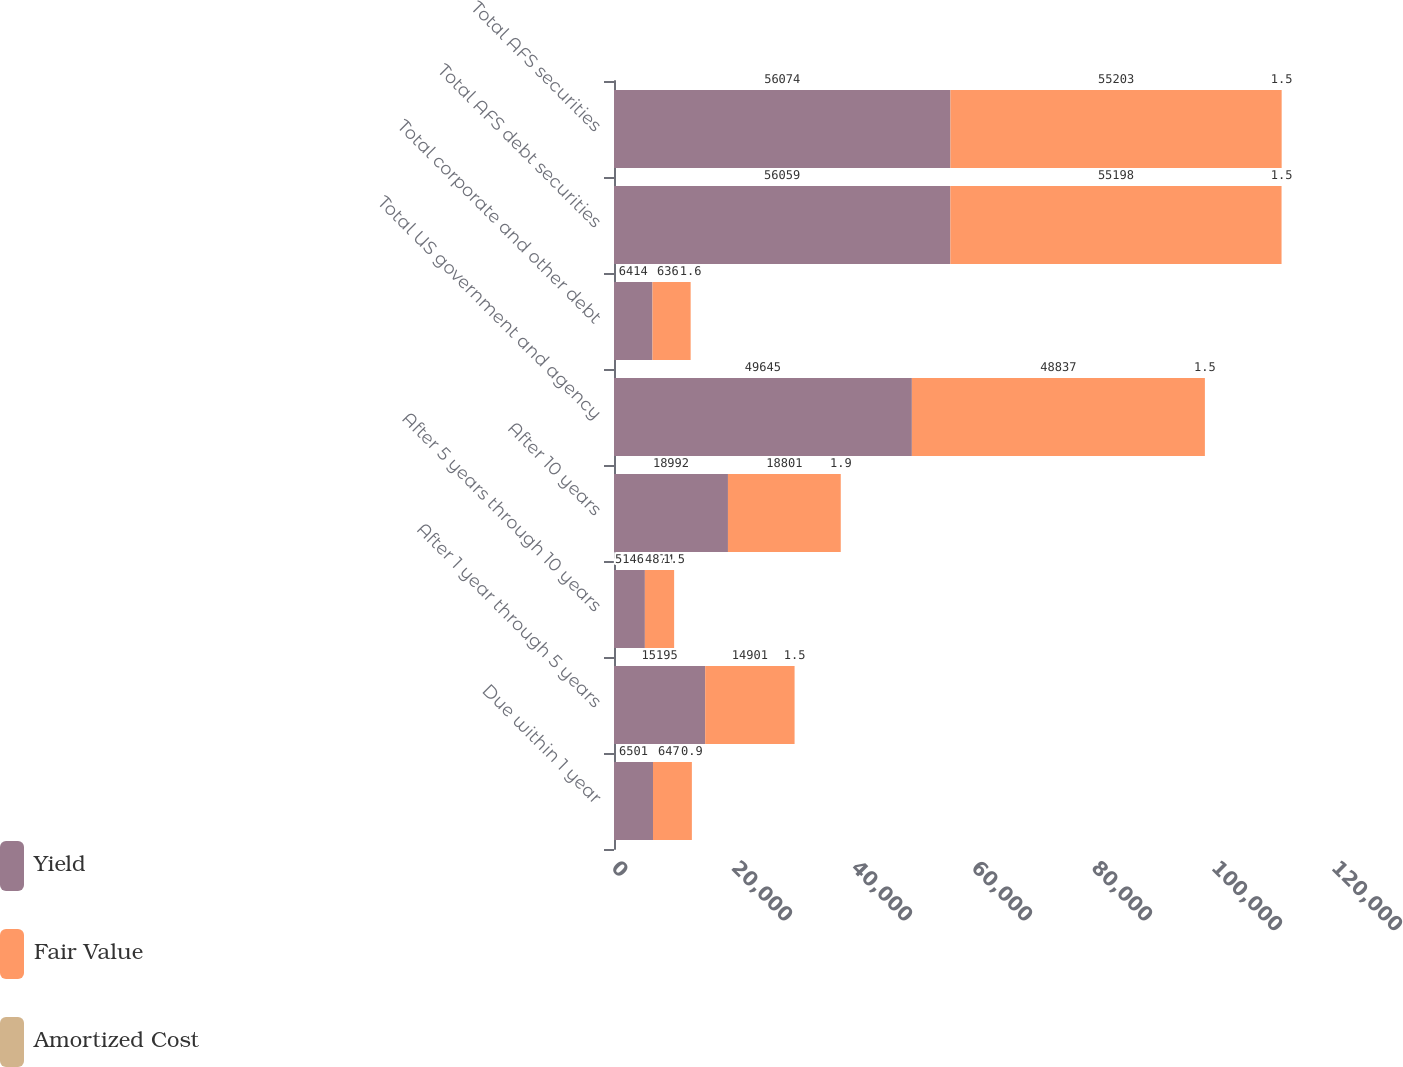<chart> <loc_0><loc_0><loc_500><loc_500><stacked_bar_chart><ecel><fcel>Due within 1 year<fcel>After 1 year through 5 years<fcel>After 5 years through 10 years<fcel>After 10 years<fcel>Total US government and agency<fcel>Total corporate and other debt<fcel>Total AFS debt securities<fcel>Total AFS securities<nl><fcel>Yield<fcel>6501<fcel>15195<fcel>5146<fcel>18992<fcel>49645<fcel>6414<fcel>56059<fcel>56074<nl><fcel>Fair Value<fcel>6478<fcel>14901<fcel>4874<fcel>18801<fcel>48837<fcel>6361<fcel>55198<fcel>55203<nl><fcel>Amortized Cost<fcel>0.9<fcel>1.5<fcel>1.5<fcel>1.9<fcel>1.5<fcel>1.6<fcel>1.5<fcel>1.5<nl></chart> 